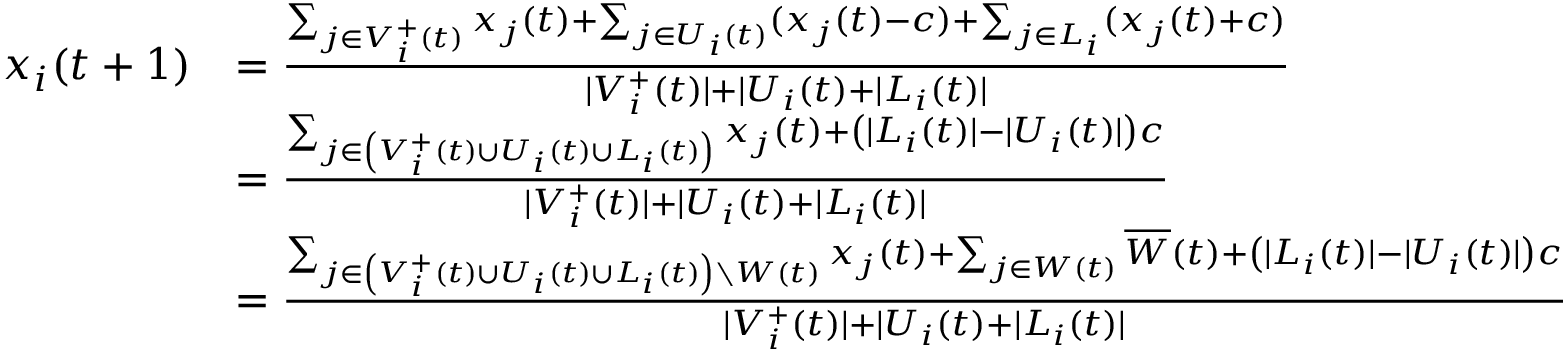Convert formula to latex. <formula><loc_0><loc_0><loc_500><loc_500>\begin{array} { r l } { x _ { i } ( t + 1 ) } & { = \frac { \sum _ { j \in V _ { i } ^ { + } ( t ) } x _ { j } ( t ) + \sum _ { j \in U _ { i } ( t ) } ( x _ { j } ( t ) - c ) + \sum _ { j \in L _ { i } } ( x _ { j } ( t ) + c ) } { | V _ { i } ^ { + } ( t ) | + | U _ { i } ( t ) + | L _ { i } ( t ) | } } \\ & { = \frac { \sum _ { j \in \left ( V _ { i } ^ { + } ( t ) \cup U _ { i } ( t ) \cup L _ { i } ( t ) \right ) } x _ { j } ( t ) + \left ( | L _ { i } ( t ) | - | U _ { i } ( t ) | \right ) c } { | V _ { i } ^ { + } ( t ) | + | U _ { i } ( t ) + | L _ { i } ( t ) | } } \\ & { = \frac { \sum _ { j \in \left ( V _ { i } ^ { + } ( t ) \cup U _ { i } ( t ) \cup L _ { i } ( t ) \right ) \ W ( t ) } x _ { j } ( t ) + \sum _ { j \in W ( t ) } \overline { W } ( t ) + \left ( | L _ { i } ( t ) | - | U _ { i } ( t ) | \right ) c } { | V _ { i } ^ { + } ( t ) | + | U _ { i } ( t ) + | L _ { i } ( t ) | } } \end{array}</formula> 